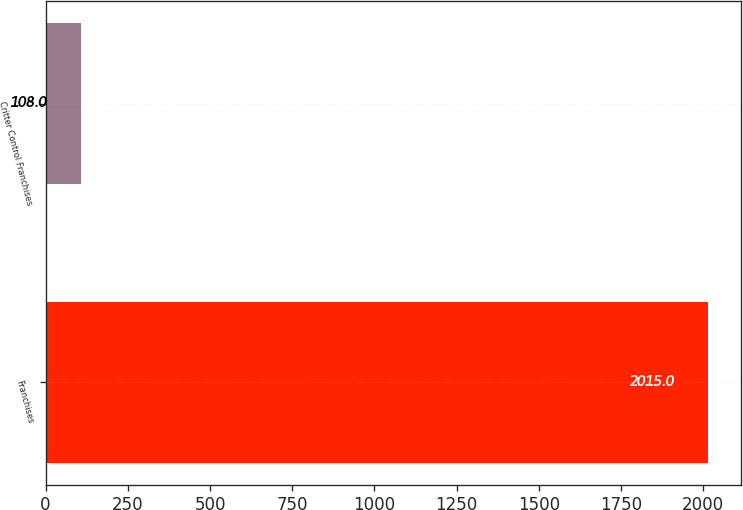<chart> <loc_0><loc_0><loc_500><loc_500><bar_chart><fcel>Franchises<fcel>Critter Control Franchises<nl><fcel>2015<fcel>108<nl></chart> 